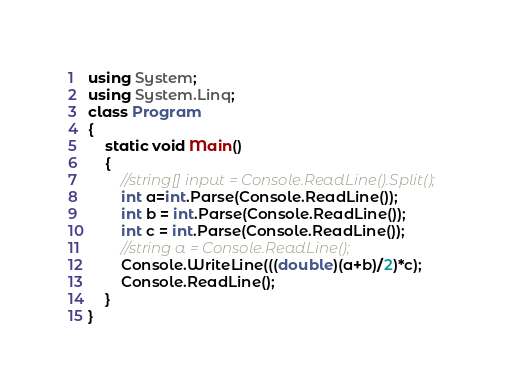<code> <loc_0><loc_0><loc_500><loc_500><_C#_>using System;
using System.Linq;
class Program
{
    static void Main()
    {
        //string[] input = Console.ReadLine().Split();
        int a=int.Parse(Console.ReadLine());
        int b = int.Parse(Console.ReadLine());
        int c = int.Parse(Console.ReadLine());
        //string a = Console.ReadLine();
        Console.WriteLine(((double)(a+b)/2)*c);
        Console.ReadLine();
    }
}
</code> 